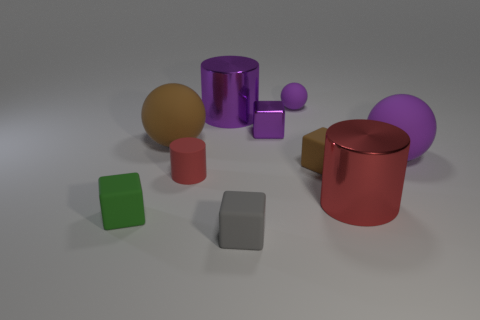Subtract all tiny brown blocks. How many blocks are left? 3 Subtract all gray cylinders. How many purple spheres are left? 2 Subtract all gray cubes. How many cubes are left? 3 Subtract 3 cylinders. How many cylinders are left? 0 Subtract all cyan cylinders. Subtract all gray blocks. How many cylinders are left? 3 Subtract 0 blue cubes. How many objects are left? 10 Subtract all spheres. How many objects are left? 7 Subtract all gray rubber things. Subtract all purple shiny cylinders. How many objects are left? 8 Add 5 purple matte balls. How many purple matte balls are left? 7 Add 8 blue cylinders. How many blue cylinders exist? 8 